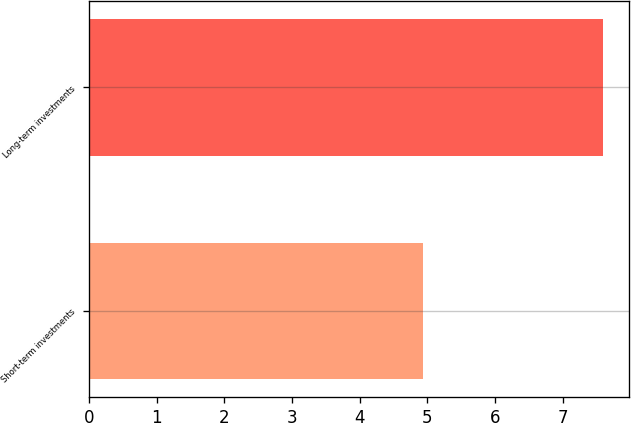Convert chart to OTSL. <chart><loc_0><loc_0><loc_500><loc_500><bar_chart><fcel>Short-term investments<fcel>Long-term investments<nl><fcel>4.94<fcel>7.6<nl></chart> 